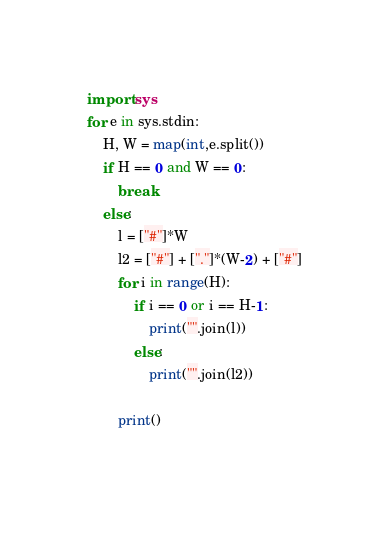Convert code to text. <code><loc_0><loc_0><loc_500><loc_500><_Python_>import sys
for e in sys.stdin:
    H, W = map(int,e.split())
    if H == 0 and W == 0:
        break
    else:
        l = ["#"]*W
        l2 = ["#"] + ["."]*(W-2) + ["#"]
        for i in range(H):
            if i == 0 or i == H-1:
                print("".join(l))
            else:
                print("".join(l2))
            
        print()
            
</code> 